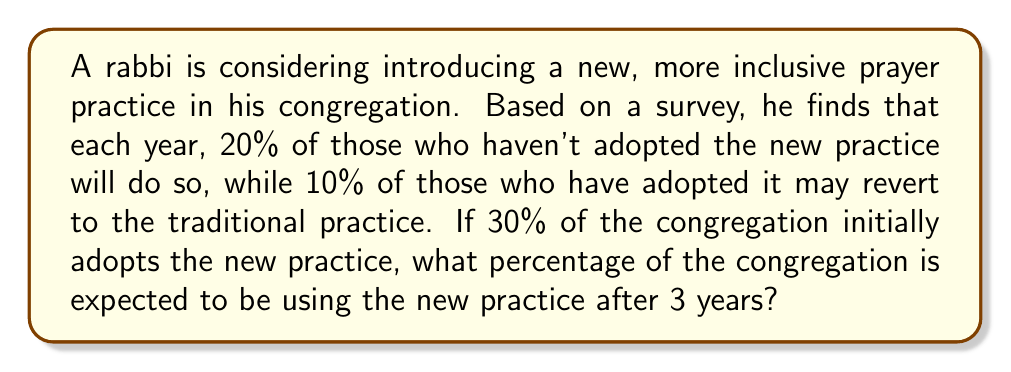Can you answer this question? Let's approach this step-by-step:

1) Let $p_n$ be the proportion of the congregation using the new practice after $n$ years.

2) We're given that $p_0 = 0.30$ (30% initial adoption).

3) For each subsequent year, we can calculate:
   $p_{n+1} = p_n + 0.20(1-p_n) - 0.10p_n$
   
   This is because:
   - $0.20(1-p_n)$ represents 20% of those not using the practice adopting it
   - $0.10p_n$ represents 10% of those using the practice reverting

4) Simplifying the equation:
   $p_{n+1} = p_n + 0.20 - 0.20p_n - 0.10p_n$
   $p_{n+1} = 0.20 + 0.70p_n$

5) Now, let's calculate for each year:

   Year 1: $p_1 = 0.20 + 0.70(0.30) = 0.20 + 0.21 = 0.41$
   
   Year 2: $p_2 = 0.20 + 0.70(0.41) = 0.20 + 0.287 = 0.487$
   
   Year 3: $p_3 = 0.20 + 0.70(0.487) = 0.20 + 0.3409 = 0.5409$

6) Converting to a percentage: $0.5409 * 100 = 54.09\%$
Answer: 54.09% 